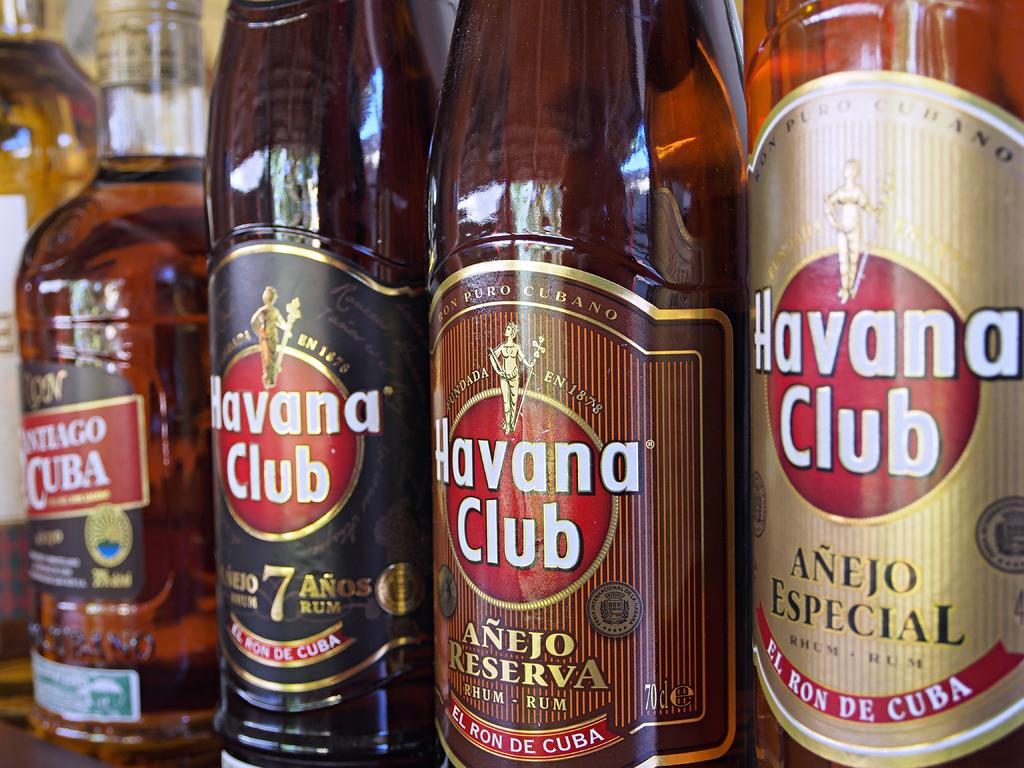<image>
Describe the image concisely. Multple bottles of Havana Club rum stand in a row. 